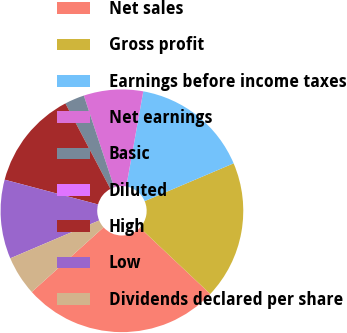<chart> <loc_0><loc_0><loc_500><loc_500><pie_chart><fcel>Net sales<fcel>Gross profit<fcel>Earnings before income taxes<fcel>Net earnings<fcel>Basic<fcel>Diluted<fcel>High<fcel>Low<fcel>Dividends declared per share<nl><fcel>26.31%<fcel>18.42%<fcel>15.79%<fcel>7.9%<fcel>2.63%<fcel>0.0%<fcel>13.16%<fcel>10.53%<fcel>5.26%<nl></chart> 